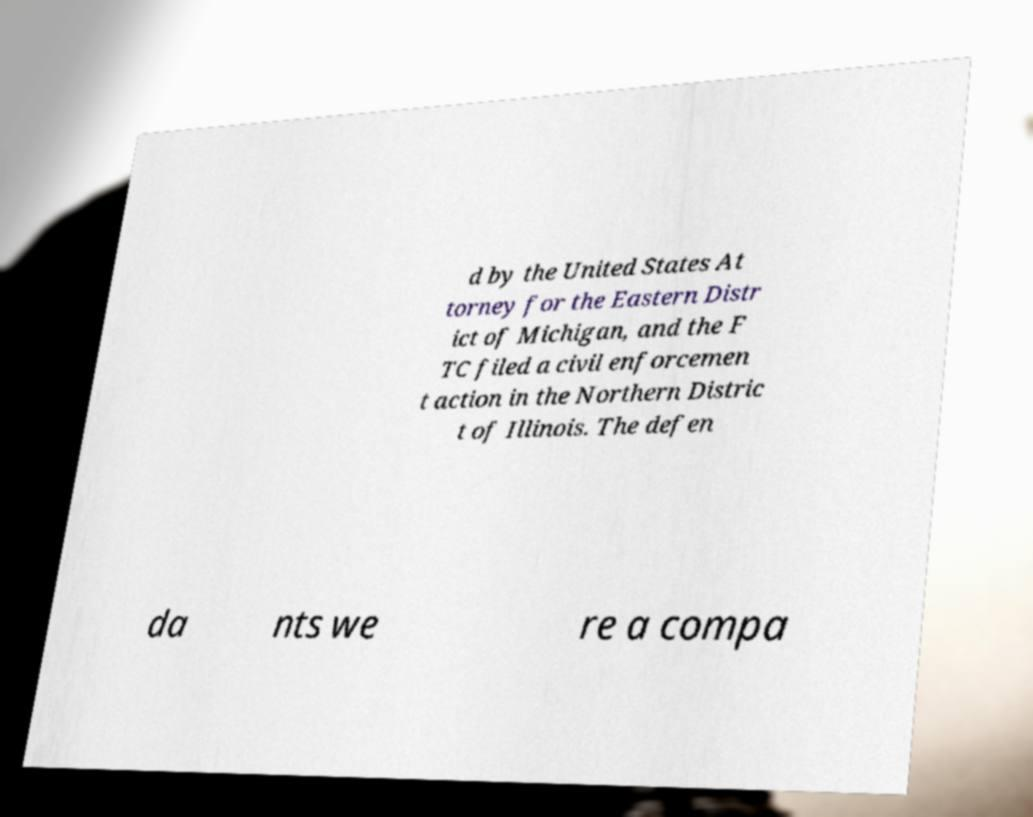For documentation purposes, I need the text within this image transcribed. Could you provide that? d by the United States At torney for the Eastern Distr ict of Michigan, and the F TC filed a civil enforcemen t action in the Northern Distric t of Illinois. The defen da nts we re a compa 